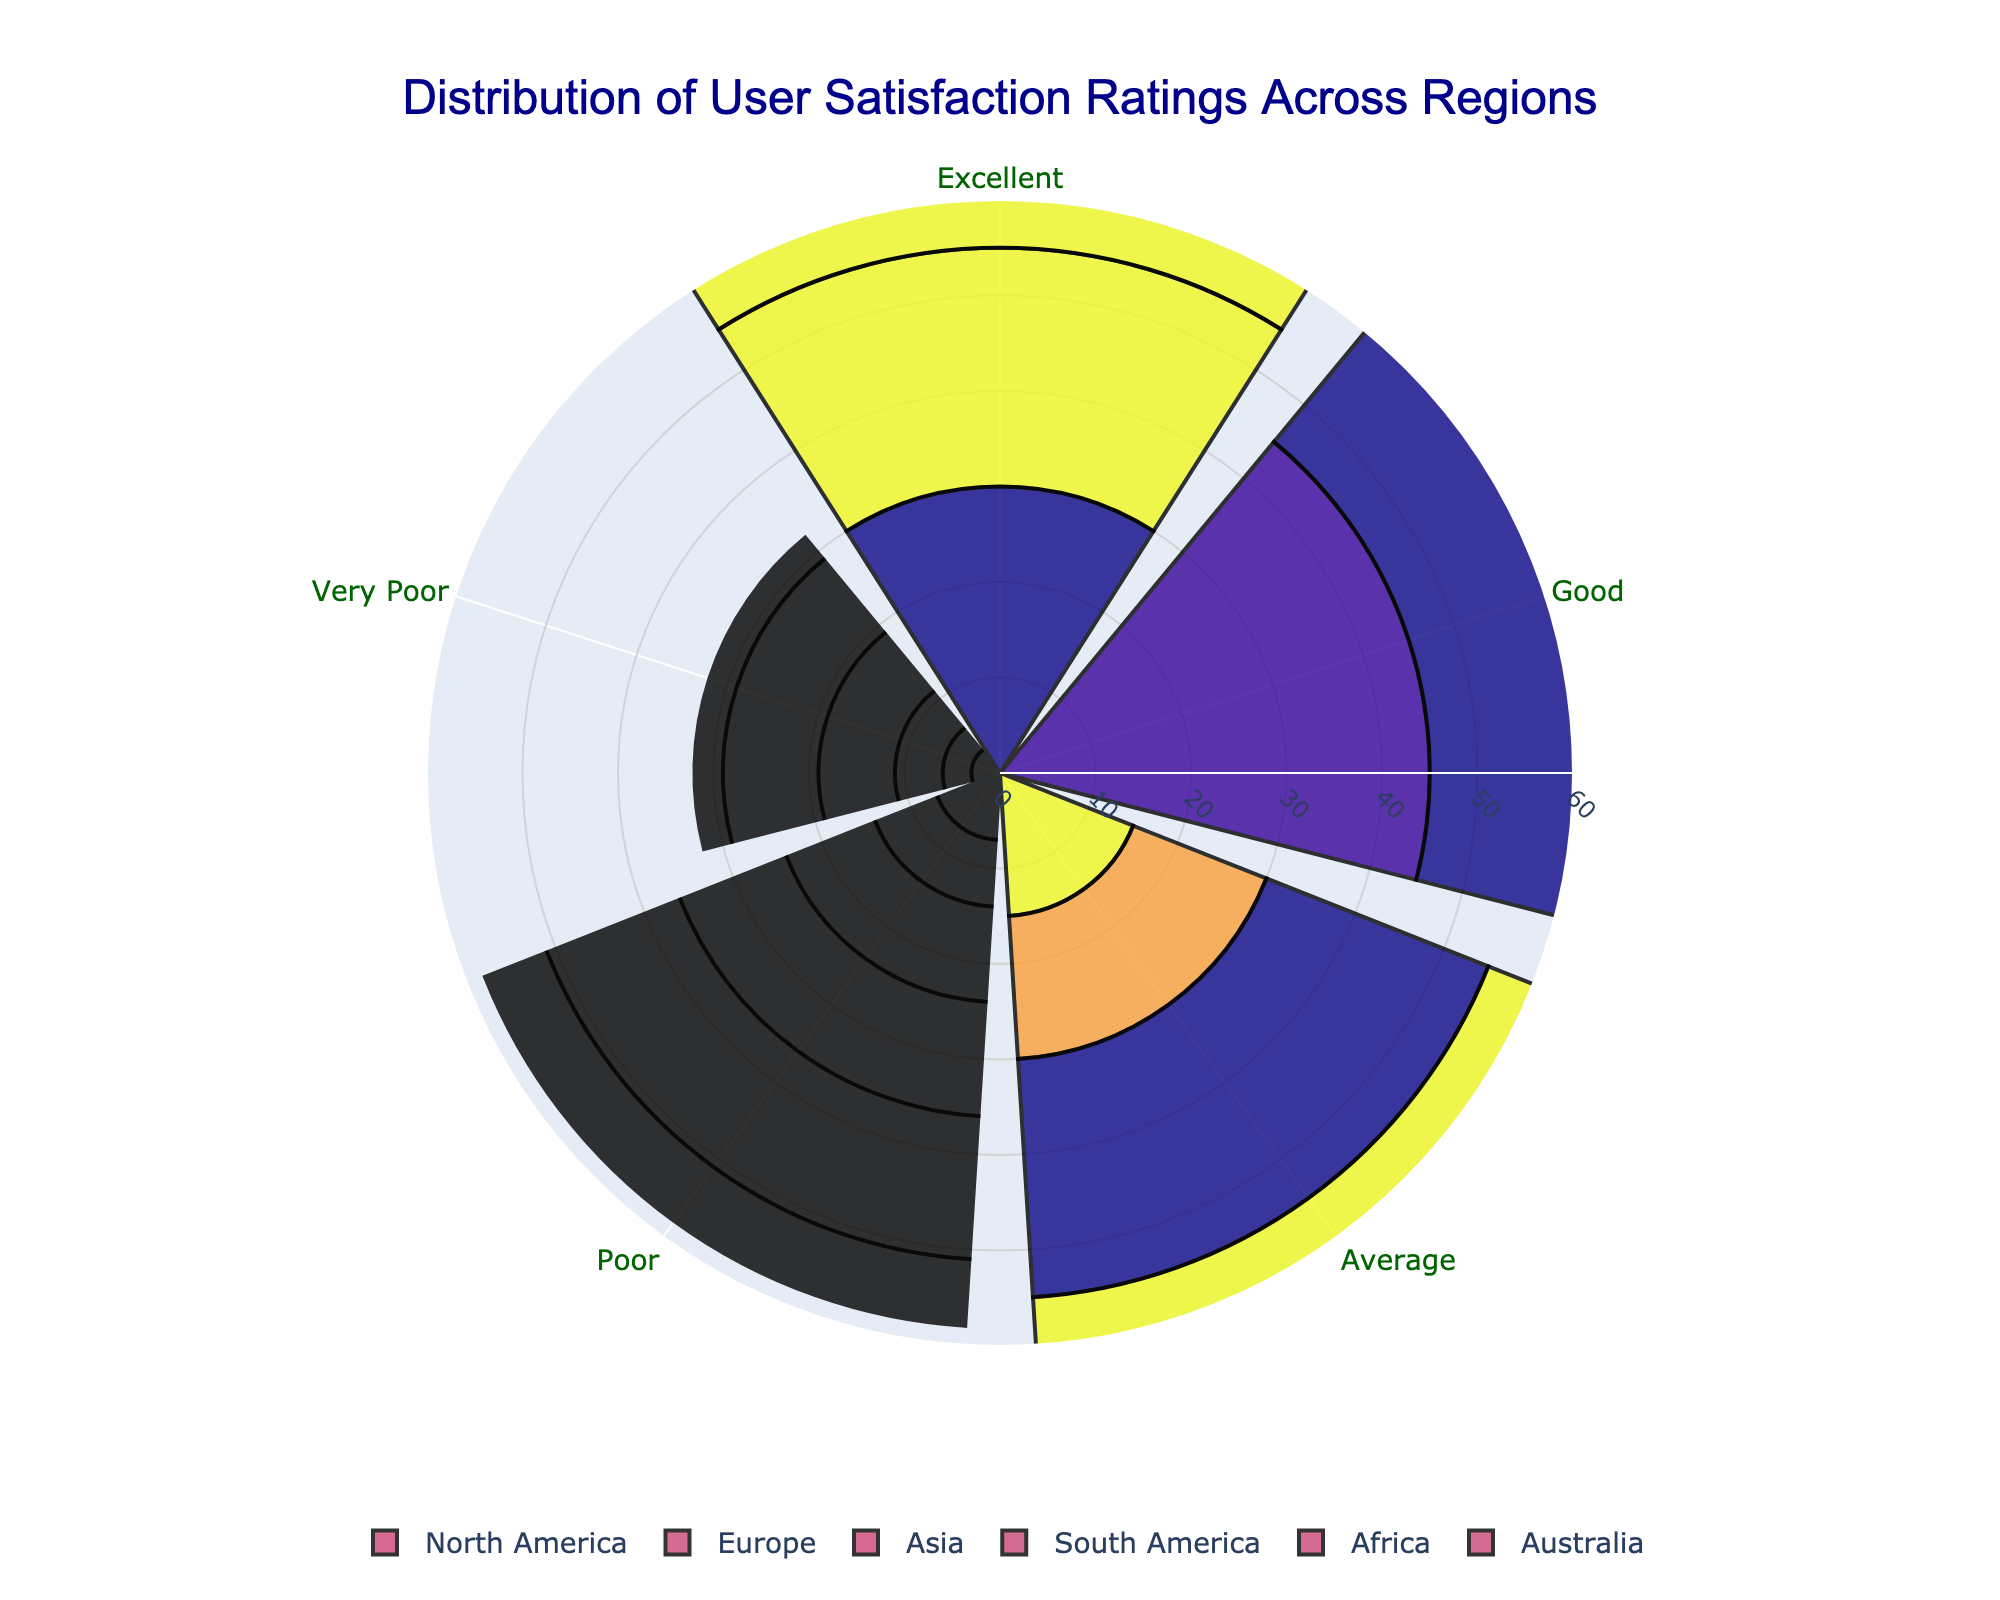What is the title of the figure? The title of the figure appears at the top and usually summarizes the main takeaway or the content being analyzed. In this case, it should be written in large font size for visibility.
Answer: Distribution of User Satisfaction Ratings Across Regions Which region has the highest percentage of 'Excellent' ratings? We need to look at the segment labeled 'Excellent' in each region's portion of the chart and compare their percentages. The highest percentage will be the answer.
Answer: North America What is the distribution of 'Average' user satisfaction ratings in Africa? We examine the 'Average' segment of the Africa region. The height of the barpolar sector corresponding to 'Average' rating shows the percentage value.
Answer: 35% Comparing Europe and Asia, which region has a higher percentage of 'Poor' ratings? To answer this, locate the 'Poor' segments for both Europe and Asia, and compare the percentages. The higher value will indicate which region has a higher percentage of 'Poor' ratings.
Answer: Asia What is the difference in the 'Very Poor' ratings between North America and South America? Find the 'Very Poor' segments for both North America and South America, note their percentages, and subtract to find the difference. Calculation: 8% (South America) - 3% (North America) = 5%
Answer: 5% Which region shows the smallest percentage of 'Good' ratings? Identify and compare the 'Good' segments for each region. The smallest value indicates the region with the smallest percentage of 'Good' ratings.
Answer: Africa What is the sum of 'Excellent' and 'Good' ratings in Australia? Add the percentages of 'Excellent' and 'Good' ratings in Australia. Calculation: 28% (Excellent) + 42% (Good) = 70%
Answer: 70% Which region has the most diverse distribution of user satisfaction ratings? This involves an overall visual assessment of the spread and variety in the length of different segments for each region to see which one appears the most varied.
Answer: South America Comparing 'Average' ratings, which region has a higher overall percentage, North America or South America? Check the percentages of 'Average' ratings in both North America and South America and directly compare them.
Answer: South America Which region has an overall higher percentage of negative ratings (Poor + Very Poor)? Calculate the total percentage of 'Poor' and 'Very Poor' ratings for each region and compare the results. For example, Africa: 15% (Poor) + 10% (Very Poor) = 25%.
Answer: Africa 